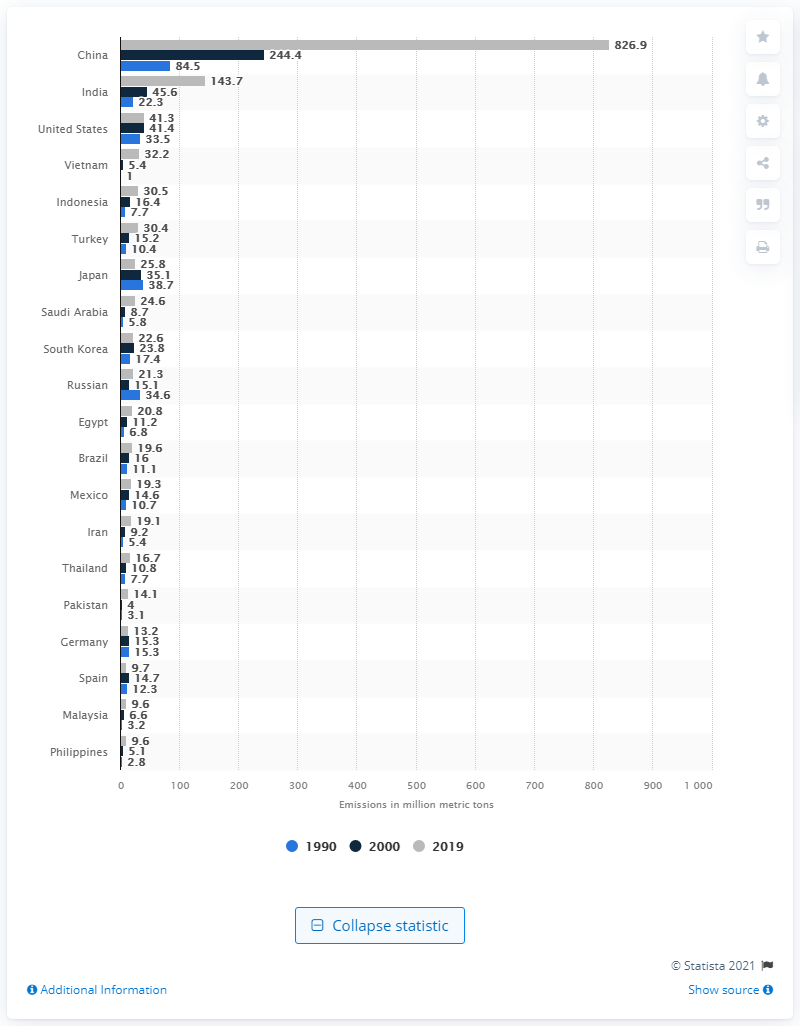Specify some key components in this picture. Japan's emissions have declined, making it one of the countries with reduced emissions. In 2019, the cement industry in China emitted a significant amount of CO2, approximately 826.9 million metric tons. The cement industry in China emitted 84.5 million metric tons of CO2 in 1990. 